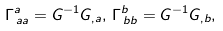<formula> <loc_0><loc_0><loc_500><loc_500>\Gamma _ { \, a a } ^ { a } = G ^ { - 1 } G _ { , a } , \, \Gamma _ { \, b b } ^ { b } = G ^ { - 1 } G _ { , b } ,</formula> 